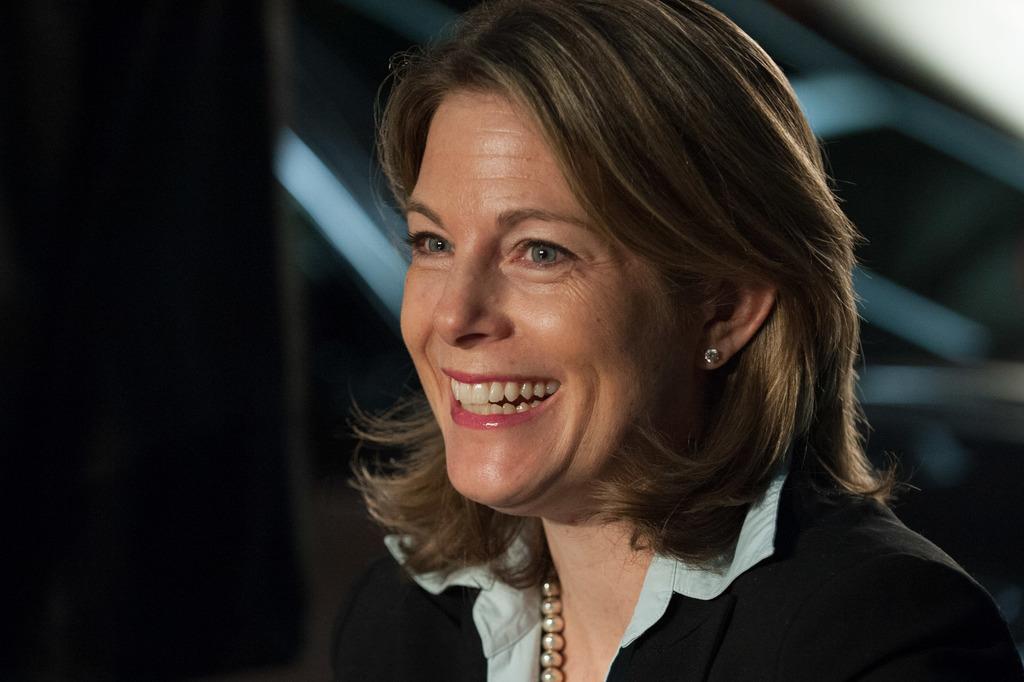In one or two sentences, can you explain what this image depicts? In the center of the image we can see a lady is smiling. In the background the image is dark. 